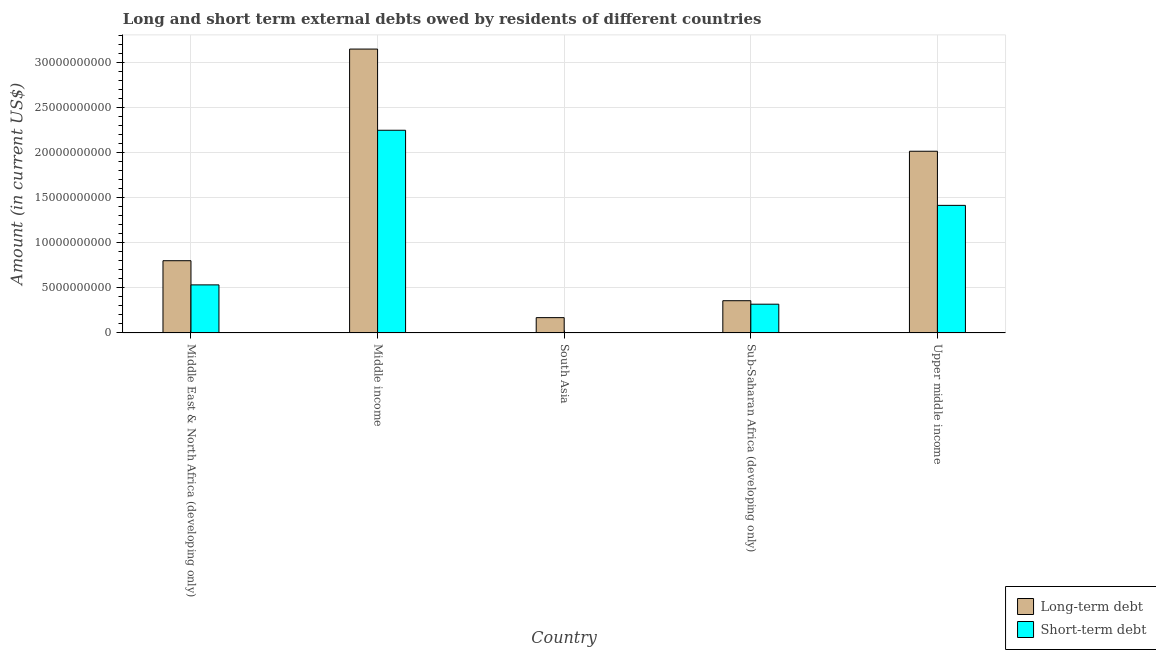How many groups of bars are there?
Ensure brevity in your answer.  5. Are the number of bars on each tick of the X-axis equal?
Give a very brief answer. Yes. How many bars are there on the 4th tick from the left?
Offer a terse response. 2. What is the label of the 2nd group of bars from the left?
Offer a terse response. Middle income. What is the short-term debts owed by residents in Upper middle income?
Offer a very short reply. 1.42e+1. Across all countries, what is the maximum short-term debts owed by residents?
Make the answer very short. 2.25e+1. Across all countries, what is the minimum short-term debts owed by residents?
Offer a very short reply. 8.00e+06. What is the total short-term debts owed by residents in the graph?
Provide a short and direct response. 4.52e+1. What is the difference between the short-term debts owed by residents in South Asia and that in Sub-Saharan Africa (developing only)?
Give a very brief answer. -3.18e+09. What is the difference between the short-term debts owed by residents in Sub-Saharan Africa (developing only) and the long-term debts owed by residents in Middle East & North Africa (developing only)?
Give a very brief answer. -4.83e+09. What is the average long-term debts owed by residents per country?
Make the answer very short. 1.30e+1. What is the difference between the short-term debts owed by residents and long-term debts owed by residents in Upper middle income?
Your answer should be compact. -6.01e+09. What is the ratio of the short-term debts owed by residents in Sub-Saharan Africa (developing only) to that in Upper middle income?
Provide a succinct answer. 0.23. What is the difference between the highest and the second highest long-term debts owed by residents?
Your response must be concise. 1.13e+1. What is the difference between the highest and the lowest long-term debts owed by residents?
Provide a short and direct response. 2.98e+1. Is the sum of the long-term debts owed by residents in Middle income and Upper middle income greater than the maximum short-term debts owed by residents across all countries?
Make the answer very short. Yes. What does the 1st bar from the left in Middle East & North Africa (developing only) represents?
Your answer should be very brief. Long-term debt. What does the 2nd bar from the right in Upper middle income represents?
Give a very brief answer. Long-term debt. How many bars are there?
Give a very brief answer. 10. Are all the bars in the graph horizontal?
Offer a terse response. No. Are the values on the major ticks of Y-axis written in scientific E-notation?
Give a very brief answer. No. Does the graph contain any zero values?
Offer a terse response. No. Does the graph contain grids?
Offer a terse response. Yes. How many legend labels are there?
Ensure brevity in your answer.  2. How are the legend labels stacked?
Give a very brief answer. Vertical. What is the title of the graph?
Make the answer very short. Long and short term external debts owed by residents of different countries. What is the Amount (in current US$) in Long-term debt in Middle East & North Africa (developing only)?
Ensure brevity in your answer.  8.02e+09. What is the Amount (in current US$) of Short-term debt in Middle East & North Africa (developing only)?
Your answer should be very brief. 5.34e+09. What is the Amount (in current US$) in Long-term debt in Middle income?
Your answer should be very brief. 3.15e+1. What is the Amount (in current US$) in Short-term debt in Middle income?
Your answer should be compact. 2.25e+1. What is the Amount (in current US$) of Long-term debt in South Asia?
Make the answer very short. 1.70e+09. What is the Amount (in current US$) in Long-term debt in Sub-Saharan Africa (developing only)?
Keep it short and to the point. 3.58e+09. What is the Amount (in current US$) of Short-term debt in Sub-Saharan Africa (developing only)?
Provide a short and direct response. 3.19e+09. What is the Amount (in current US$) of Long-term debt in Upper middle income?
Offer a terse response. 2.02e+1. What is the Amount (in current US$) of Short-term debt in Upper middle income?
Keep it short and to the point. 1.42e+1. Across all countries, what is the maximum Amount (in current US$) of Long-term debt?
Provide a short and direct response. 3.15e+1. Across all countries, what is the maximum Amount (in current US$) in Short-term debt?
Make the answer very short. 2.25e+1. Across all countries, what is the minimum Amount (in current US$) in Long-term debt?
Your answer should be very brief. 1.70e+09. Across all countries, what is the minimum Amount (in current US$) of Short-term debt?
Make the answer very short. 8.00e+06. What is the total Amount (in current US$) of Long-term debt in the graph?
Make the answer very short. 6.50e+1. What is the total Amount (in current US$) of Short-term debt in the graph?
Your answer should be compact. 4.52e+1. What is the difference between the Amount (in current US$) in Long-term debt in Middle East & North Africa (developing only) and that in Middle income?
Keep it short and to the point. -2.35e+1. What is the difference between the Amount (in current US$) of Short-term debt in Middle East & North Africa (developing only) and that in Middle income?
Give a very brief answer. -1.72e+1. What is the difference between the Amount (in current US$) in Long-term debt in Middle East & North Africa (developing only) and that in South Asia?
Ensure brevity in your answer.  6.32e+09. What is the difference between the Amount (in current US$) in Short-term debt in Middle East & North Africa (developing only) and that in South Asia?
Keep it short and to the point. 5.33e+09. What is the difference between the Amount (in current US$) in Long-term debt in Middle East & North Africa (developing only) and that in Sub-Saharan Africa (developing only)?
Offer a terse response. 4.44e+09. What is the difference between the Amount (in current US$) in Short-term debt in Middle East & North Africa (developing only) and that in Sub-Saharan Africa (developing only)?
Your answer should be compact. 2.14e+09. What is the difference between the Amount (in current US$) of Long-term debt in Middle East & North Africa (developing only) and that in Upper middle income?
Provide a succinct answer. -1.22e+1. What is the difference between the Amount (in current US$) of Short-term debt in Middle East & North Africa (developing only) and that in Upper middle income?
Keep it short and to the point. -8.83e+09. What is the difference between the Amount (in current US$) of Long-term debt in Middle income and that in South Asia?
Offer a terse response. 2.98e+1. What is the difference between the Amount (in current US$) in Short-term debt in Middle income and that in South Asia?
Offer a very short reply. 2.25e+1. What is the difference between the Amount (in current US$) in Long-term debt in Middle income and that in Sub-Saharan Africa (developing only)?
Provide a short and direct response. 2.79e+1. What is the difference between the Amount (in current US$) in Short-term debt in Middle income and that in Sub-Saharan Africa (developing only)?
Provide a succinct answer. 1.93e+1. What is the difference between the Amount (in current US$) of Long-term debt in Middle income and that in Upper middle income?
Offer a terse response. 1.13e+1. What is the difference between the Amount (in current US$) in Short-term debt in Middle income and that in Upper middle income?
Your response must be concise. 8.34e+09. What is the difference between the Amount (in current US$) in Long-term debt in South Asia and that in Sub-Saharan Africa (developing only)?
Offer a very short reply. -1.88e+09. What is the difference between the Amount (in current US$) of Short-term debt in South Asia and that in Sub-Saharan Africa (developing only)?
Provide a short and direct response. -3.18e+09. What is the difference between the Amount (in current US$) of Long-term debt in South Asia and that in Upper middle income?
Make the answer very short. -1.85e+1. What is the difference between the Amount (in current US$) in Short-term debt in South Asia and that in Upper middle income?
Ensure brevity in your answer.  -1.42e+1. What is the difference between the Amount (in current US$) of Long-term debt in Sub-Saharan Africa (developing only) and that in Upper middle income?
Your answer should be compact. -1.66e+1. What is the difference between the Amount (in current US$) in Short-term debt in Sub-Saharan Africa (developing only) and that in Upper middle income?
Your answer should be very brief. -1.10e+1. What is the difference between the Amount (in current US$) in Long-term debt in Middle East & North Africa (developing only) and the Amount (in current US$) in Short-term debt in Middle income?
Make the answer very short. -1.45e+1. What is the difference between the Amount (in current US$) in Long-term debt in Middle East & North Africa (developing only) and the Amount (in current US$) in Short-term debt in South Asia?
Your answer should be very brief. 8.01e+09. What is the difference between the Amount (in current US$) in Long-term debt in Middle East & North Africa (developing only) and the Amount (in current US$) in Short-term debt in Sub-Saharan Africa (developing only)?
Ensure brevity in your answer.  4.83e+09. What is the difference between the Amount (in current US$) of Long-term debt in Middle East & North Africa (developing only) and the Amount (in current US$) of Short-term debt in Upper middle income?
Offer a very short reply. -6.14e+09. What is the difference between the Amount (in current US$) of Long-term debt in Middle income and the Amount (in current US$) of Short-term debt in South Asia?
Give a very brief answer. 3.15e+1. What is the difference between the Amount (in current US$) in Long-term debt in Middle income and the Amount (in current US$) in Short-term debt in Sub-Saharan Africa (developing only)?
Make the answer very short. 2.83e+1. What is the difference between the Amount (in current US$) of Long-term debt in Middle income and the Amount (in current US$) of Short-term debt in Upper middle income?
Keep it short and to the point. 1.74e+1. What is the difference between the Amount (in current US$) of Long-term debt in South Asia and the Amount (in current US$) of Short-term debt in Sub-Saharan Africa (developing only)?
Offer a very short reply. -1.49e+09. What is the difference between the Amount (in current US$) in Long-term debt in South Asia and the Amount (in current US$) in Short-term debt in Upper middle income?
Ensure brevity in your answer.  -1.25e+1. What is the difference between the Amount (in current US$) of Long-term debt in Sub-Saharan Africa (developing only) and the Amount (in current US$) of Short-term debt in Upper middle income?
Provide a short and direct response. -1.06e+1. What is the average Amount (in current US$) in Long-term debt per country?
Your response must be concise. 1.30e+1. What is the average Amount (in current US$) in Short-term debt per country?
Give a very brief answer. 9.04e+09. What is the difference between the Amount (in current US$) in Long-term debt and Amount (in current US$) in Short-term debt in Middle East & North Africa (developing only)?
Keep it short and to the point. 2.68e+09. What is the difference between the Amount (in current US$) in Long-term debt and Amount (in current US$) in Short-term debt in Middle income?
Your response must be concise. 9.01e+09. What is the difference between the Amount (in current US$) in Long-term debt and Amount (in current US$) in Short-term debt in South Asia?
Give a very brief answer. 1.69e+09. What is the difference between the Amount (in current US$) of Long-term debt and Amount (in current US$) of Short-term debt in Sub-Saharan Africa (developing only)?
Make the answer very short. 3.87e+08. What is the difference between the Amount (in current US$) of Long-term debt and Amount (in current US$) of Short-term debt in Upper middle income?
Make the answer very short. 6.01e+09. What is the ratio of the Amount (in current US$) of Long-term debt in Middle East & North Africa (developing only) to that in Middle income?
Ensure brevity in your answer.  0.25. What is the ratio of the Amount (in current US$) in Short-term debt in Middle East & North Africa (developing only) to that in Middle income?
Your answer should be very brief. 0.24. What is the ratio of the Amount (in current US$) of Long-term debt in Middle East & North Africa (developing only) to that in South Asia?
Make the answer very short. 4.72. What is the ratio of the Amount (in current US$) in Short-term debt in Middle East & North Africa (developing only) to that in South Asia?
Your response must be concise. 666.88. What is the ratio of the Amount (in current US$) in Long-term debt in Middle East & North Africa (developing only) to that in Sub-Saharan Africa (developing only)?
Offer a very short reply. 2.24. What is the ratio of the Amount (in current US$) in Short-term debt in Middle East & North Africa (developing only) to that in Sub-Saharan Africa (developing only)?
Ensure brevity in your answer.  1.67. What is the ratio of the Amount (in current US$) of Long-term debt in Middle East & North Africa (developing only) to that in Upper middle income?
Offer a terse response. 0.4. What is the ratio of the Amount (in current US$) of Short-term debt in Middle East & North Africa (developing only) to that in Upper middle income?
Make the answer very short. 0.38. What is the ratio of the Amount (in current US$) of Long-term debt in Middle income to that in South Asia?
Give a very brief answer. 18.55. What is the ratio of the Amount (in current US$) of Short-term debt in Middle income to that in South Asia?
Ensure brevity in your answer.  2812.46. What is the ratio of the Amount (in current US$) in Long-term debt in Middle income to that in Sub-Saharan Africa (developing only)?
Keep it short and to the point. 8.81. What is the ratio of the Amount (in current US$) in Short-term debt in Middle income to that in Sub-Saharan Africa (developing only)?
Offer a terse response. 7.05. What is the ratio of the Amount (in current US$) of Long-term debt in Middle income to that in Upper middle income?
Ensure brevity in your answer.  1.56. What is the ratio of the Amount (in current US$) of Short-term debt in Middle income to that in Upper middle income?
Offer a very short reply. 1.59. What is the ratio of the Amount (in current US$) in Long-term debt in South Asia to that in Sub-Saharan Africa (developing only)?
Make the answer very short. 0.47. What is the ratio of the Amount (in current US$) in Short-term debt in South Asia to that in Sub-Saharan Africa (developing only)?
Keep it short and to the point. 0. What is the ratio of the Amount (in current US$) of Long-term debt in South Asia to that in Upper middle income?
Offer a very short reply. 0.08. What is the ratio of the Amount (in current US$) of Short-term debt in South Asia to that in Upper middle income?
Offer a very short reply. 0. What is the ratio of the Amount (in current US$) of Long-term debt in Sub-Saharan Africa (developing only) to that in Upper middle income?
Your response must be concise. 0.18. What is the ratio of the Amount (in current US$) in Short-term debt in Sub-Saharan Africa (developing only) to that in Upper middle income?
Ensure brevity in your answer.  0.23. What is the difference between the highest and the second highest Amount (in current US$) in Long-term debt?
Your answer should be compact. 1.13e+1. What is the difference between the highest and the second highest Amount (in current US$) of Short-term debt?
Keep it short and to the point. 8.34e+09. What is the difference between the highest and the lowest Amount (in current US$) of Long-term debt?
Your answer should be compact. 2.98e+1. What is the difference between the highest and the lowest Amount (in current US$) in Short-term debt?
Make the answer very short. 2.25e+1. 